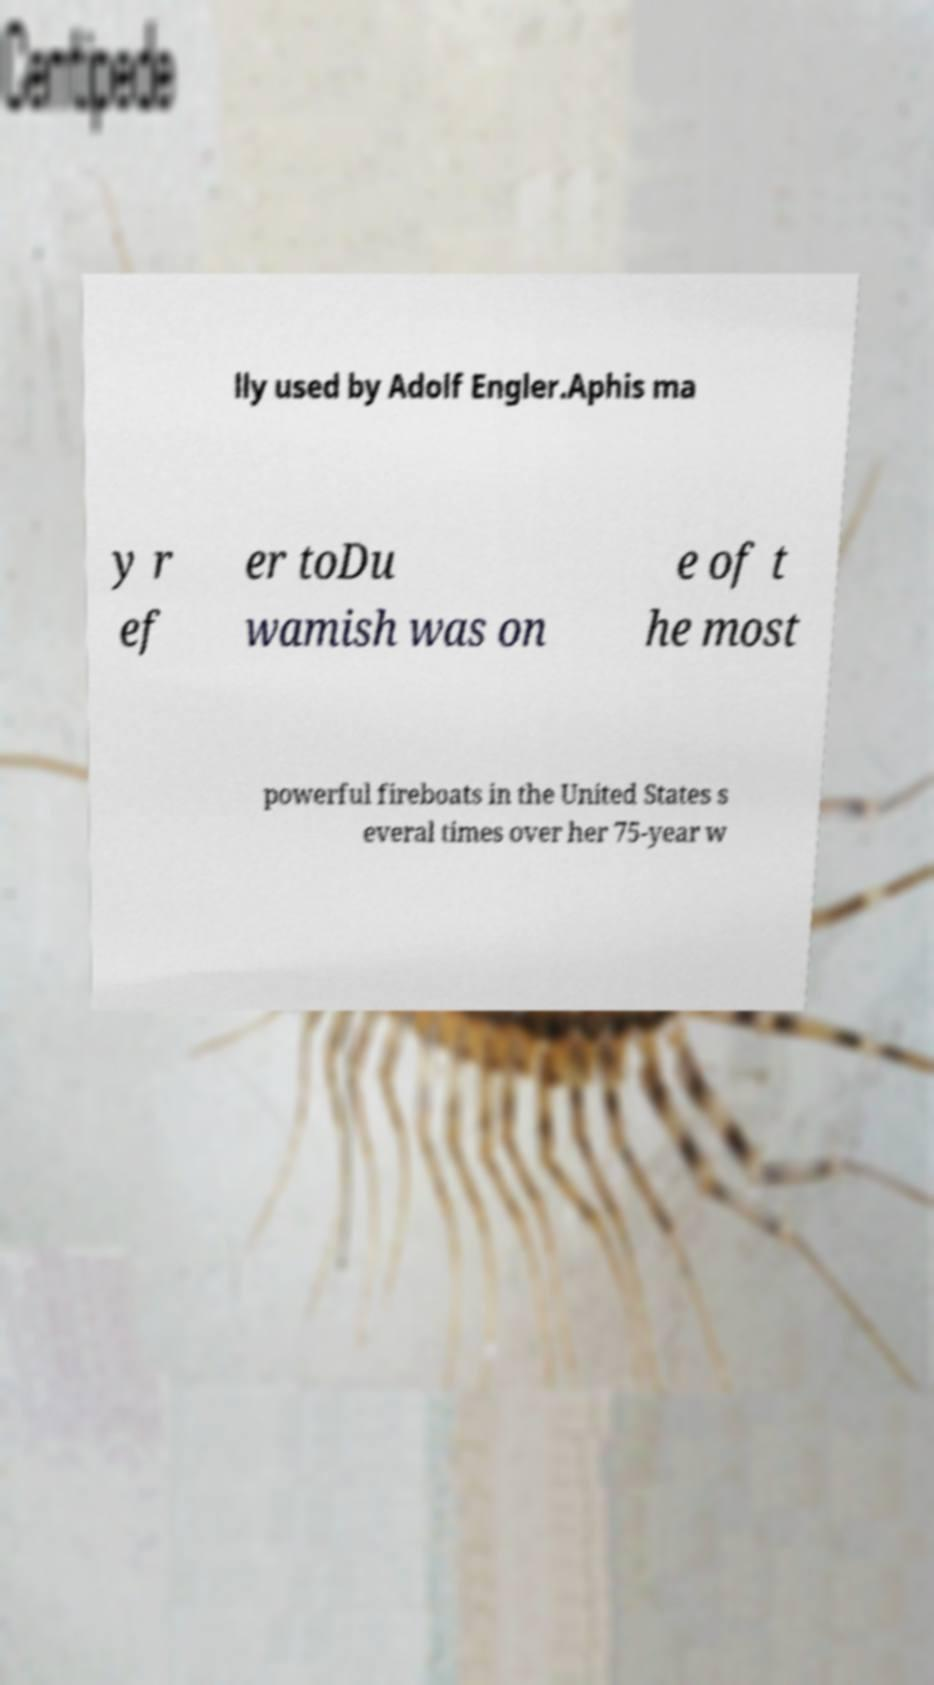There's text embedded in this image that I need extracted. Can you transcribe it verbatim? lly used by Adolf Engler.Aphis ma y r ef er toDu wamish was on e of t he most powerful fireboats in the United States s everal times over her 75-year w 